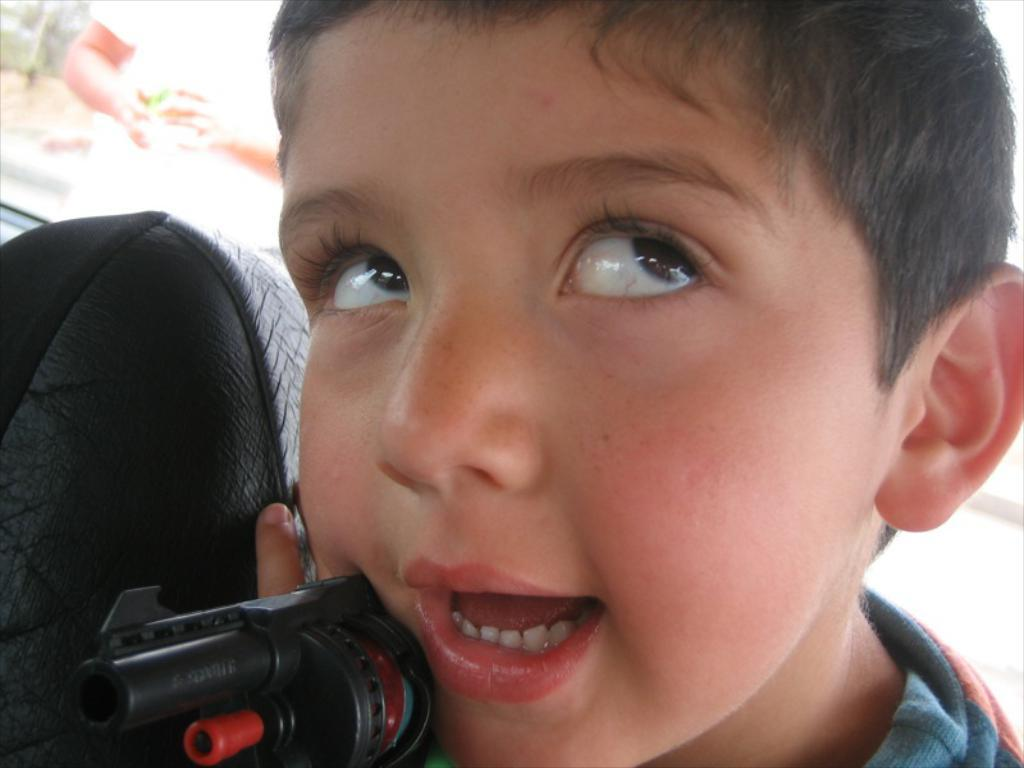Who is the main subject in the image? There is a boy in the image. What is the boy doing in the image? The boy is seated in a vehicle. What is the boy holding in his hand? The boy is holding a toy gun in his hand. What can be seen through the vehicle's glass? There is a human and trees visible through the vehicle's glass. What time of day is it in the image, and what type of haircut does the judge have? The time of day is not mentioned in the image, and there is no judge present. Therefore, we cannot determine the time of day or the judge's haircut. 